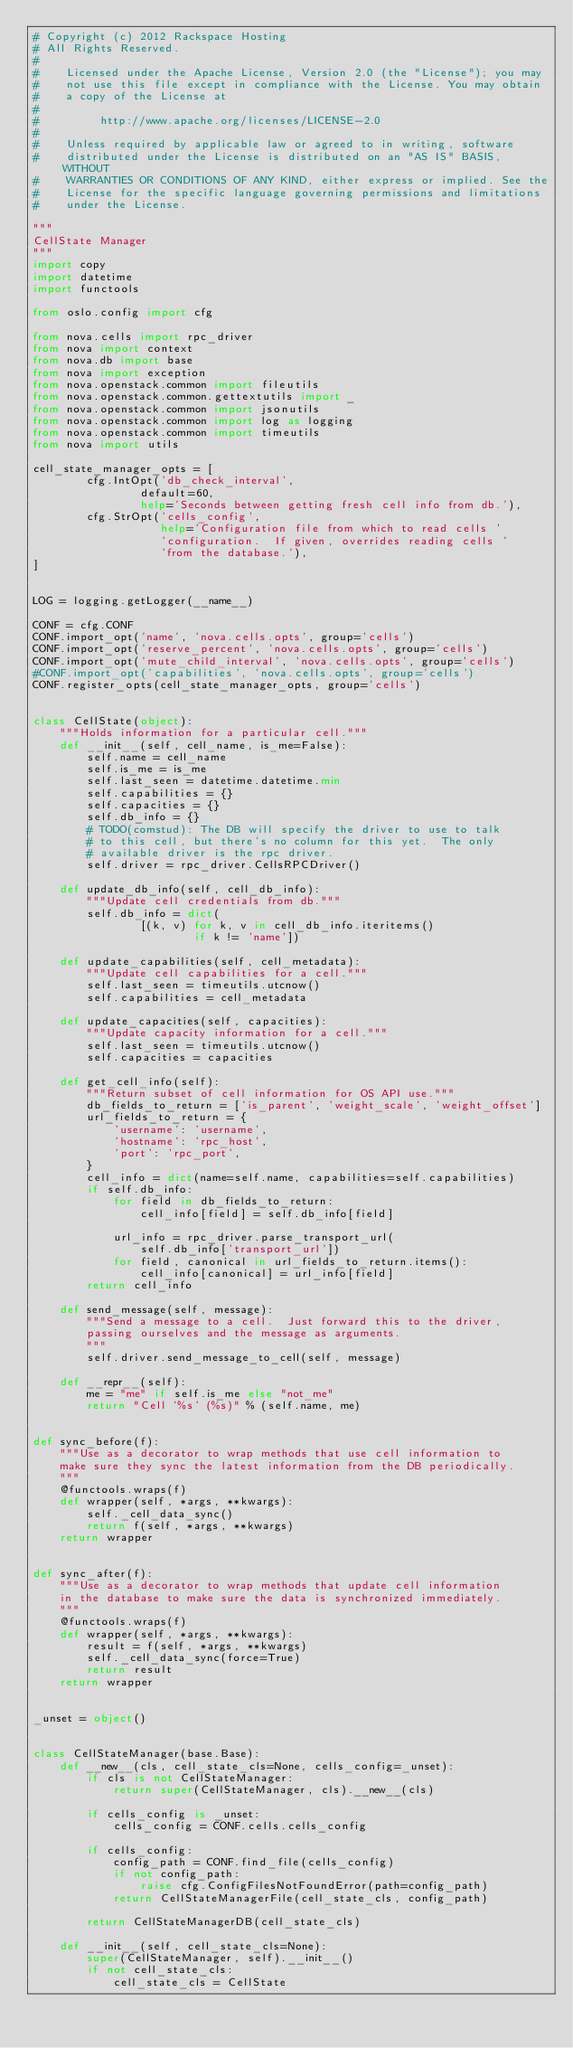Convert code to text. <code><loc_0><loc_0><loc_500><loc_500><_Python_># Copyright (c) 2012 Rackspace Hosting
# All Rights Reserved.
#
#    Licensed under the Apache License, Version 2.0 (the "License"); you may
#    not use this file except in compliance with the License. You may obtain
#    a copy of the License at
#
#         http://www.apache.org/licenses/LICENSE-2.0
#
#    Unless required by applicable law or agreed to in writing, software
#    distributed under the License is distributed on an "AS IS" BASIS, WITHOUT
#    WARRANTIES OR CONDITIONS OF ANY KIND, either express or implied. See the
#    License for the specific language governing permissions and limitations
#    under the License.

"""
CellState Manager
"""
import copy
import datetime
import functools

from oslo.config import cfg

from nova.cells import rpc_driver
from nova import context
from nova.db import base
from nova import exception
from nova.openstack.common import fileutils
from nova.openstack.common.gettextutils import _
from nova.openstack.common import jsonutils
from nova.openstack.common import log as logging
from nova.openstack.common import timeutils
from nova import utils

cell_state_manager_opts = [
        cfg.IntOpt('db_check_interval',
                default=60,
                help='Seconds between getting fresh cell info from db.'),
        cfg.StrOpt('cells_config',
                   help='Configuration file from which to read cells '
                   'configuration.  If given, overrides reading cells '
                   'from the database.'),
]


LOG = logging.getLogger(__name__)

CONF = cfg.CONF
CONF.import_opt('name', 'nova.cells.opts', group='cells')
CONF.import_opt('reserve_percent', 'nova.cells.opts', group='cells')
CONF.import_opt('mute_child_interval', 'nova.cells.opts', group='cells')
#CONF.import_opt('capabilities', 'nova.cells.opts', group='cells')
CONF.register_opts(cell_state_manager_opts, group='cells')


class CellState(object):
    """Holds information for a particular cell."""
    def __init__(self, cell_name, is_me=False):
        self.name = cell_name
        self.is_me = is_me
        self.last_seen = datetime.datetime.min
        self.capabilities = {}
        self.capacities = {}
        self.db_info = {}
        # TODO(comstud): The DB will specify the driver to use to talk
        # to this cell, but there's no column for this yet.  The only
        # available driver is the rpc driver.
        self.driver = rpc_driver.CellsRPCDriver()

    def update_db_info(self, cell_db_info):
        """Update cell credentials from db."""
        self.db_info = dict(
                [(k, v) for k, v in cell_db_info.iteritems()
                        if k != 'name'])

    def update_capabilities(self, cell_metadata):
        """Update cell capabilities for a cell."""
        self.last_seen = timeutils.utcnow()
        self.capabilities = cell_metadata

    def update_capacities(self, capacities):
        """Update capacity information for a cell."""
        self.last_seen = timeutils.utcnow()
        self.capacities = capacities

    def get_cell_info(self):
        """Return subset of cell information for OS API use."""
        db_fields_to_return = ['is_parent', 'weight_scale', 'weight_offset']
        url_fields_to_return = {
            'username': 'username',
            'hostname': 'rpc_host',
            'port': 'rpc_port',
        }
        cell_info = dict(name=self.name, capabilities=self.capabilities)
        if self.db_info:
            for field in db_fields_to_return:
                cell_info[field] = self.db_info[field]

            url_info = rpc_driver.parse_transport_url(
                self.db_info['transport_url'])
            for field, canonical in url_fields_to_return.items():
                cell_info[canonical] = url_info[field]
        return cell_info

    def send_message(self, message):
        """Send a message to a cell.  Just forward this to the driver,
        passing ourselves and the message as arguments.
        """
        self.driver.send_message_to_cell(self, message)

    def __repr__(self):
        me = "me" if self.is_me else "not_me"
        return "Cell '%s' (%s)" % (self.name, me)


def sync_before(f):
    """Use as a decorator to wrap methods that use cell information to
    make sure they sync the latest information from the DB periodically.
    """
    @functools.wraps(f)
    def wrapper(self, *args, **kwargs):
        self._cell_data_sync()
        return f(self, *args, **kwargs)
    return wrapper


def sync_after(f):
    """Use as a decorator to wrap methods that update cell information
    in the database to make sure the data is synchronized immediately.
    """
    @functools.wraps(f)
    def wrapper(self, *args, **kwargs):
        result = f(self, *args, **kwargs)
        self._cell_data_sync(force=True)
        return result
    return wrapper


_unset = object()


class CellStateManager(base.Base):
    def __new__(cls, cell_state_cls=None, cells_config=_unset):
        if cls is not CellStateManager:
            return super(CellStateManager, cls).__new__(cls)

        if cells_config is _unset:
            cells_config = CONF.cells.cells_config

        if cells_config:
            config_path = CONF.find_file(cells_config)
            if not config_path:
                raise cfg.ConfigFilesNotFoundError(path=config_path)
            return CellStateManagerFile(cell_state_cls, config_path)

        return CellStateManagerDB(cell_state_cls)

    def __init__(self, cell_state_cls=None):
        super(CellStateManager, self).__init__()
        if not cell_state_cls:
            cell_state_cls = CellState</code> 